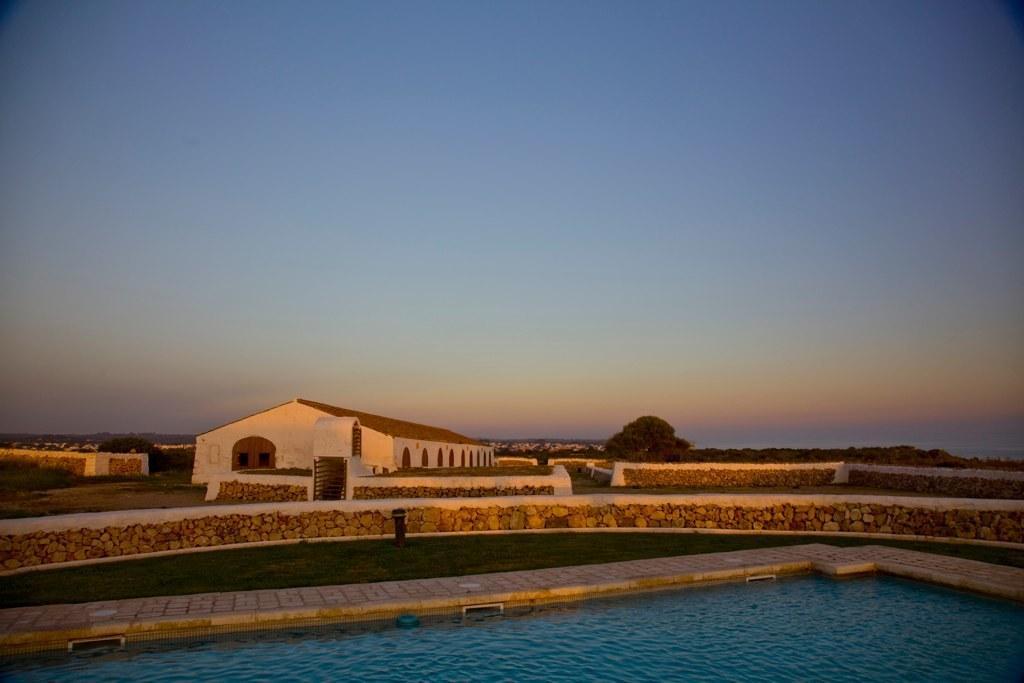What structure is located in the middle of the image? There is a house in the middle of the image. What can be seen at the bottom of the image? There is a swimming pool at the bottom of the image. What is visible at the top of the image? The sky is visible at the top of the image. What type of vegetation is in the background of the image? There are trees in the background of the image. What else can be seen in the background of the image? There are buildings at some distance in the background of the image. What type of meat is being served to the visitor in the image? There is no meat or visitor present in the image. What type of town is visible in the background of the image? The image does not depict a town; it shows a house, a swimming pool, trees, and buildings in the background. 